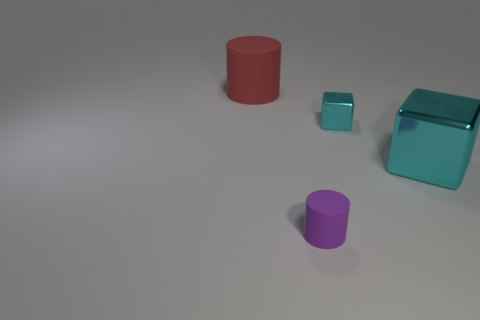The cylinder that is on the left side of the tiny purple object is what color?
Give a very brief answer. Red. Are there any red cylinders that are in front of the purple rubber cylinder that is in front of the big red rubber cylinder?
Give a very brief answer. No. Are there fewer large red objects than cubes?
Offer a terse response. Yes. What material is the small purple thing in front of the cyan shiny object on the left side of the large cyan object?
Ensure brevity in your answer.  Rubber. Do the purple thing and the red matte cylinder have the same size?
Ensure brevity in your answer.  No. What number of things are either brown things or matte cylinders?
Your answer should be very brief. 2. What is the size of the object that is left of the tiny shiny cube and in front of the big red object?
Your answer should be very brief. Small. Is the number of small matte objects that are in front of the purple cylinder less than the number of small metal blocks?
Your answer should be very brief. Yes. What shape is the other thing that is the same material as the purple object?
Provide a succinct answer. Cylinder. Is the shape of the large thing on the right side of the red rubber cylinder the same as the tiny thing that is on the right side of the purple rubber cylinder?
Offer a very short reply. Yes. 